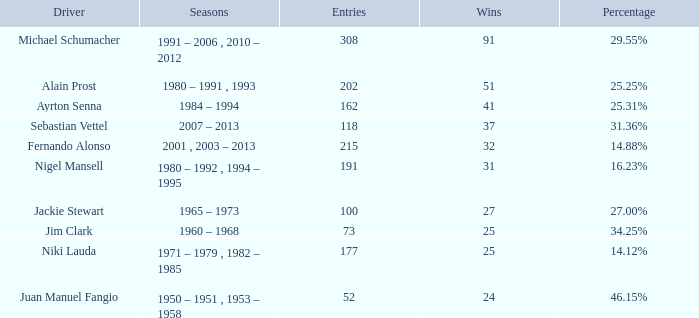Which driver has 162 entries? Ayrton Senna. 